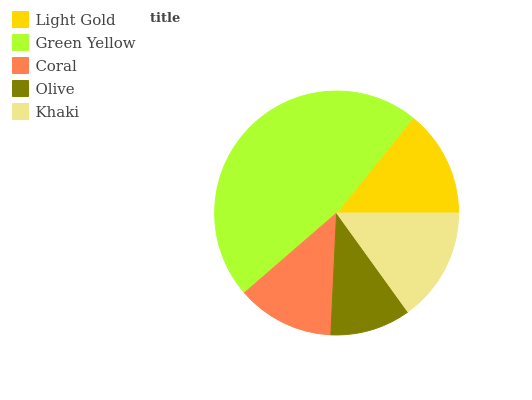Is Olive the minimum?
Answer yes or no. Yes. Is Green Yellow the maximum?
Answer yes or no. Yes. Is Coral the minimum?
Answer yes or no. No. Is Coral the maximum?
Answer yes or no. No. Is Green Yellow greater than Coral?
Answer yes or no. Yes. Is Coral less than Green Yellow?
Answer yes or no. Yes. Is Coral greater than Green Yellow?
Answer yes or no. No. Is Green Yellow less than Coral?
Answer yes or no. No. Is Light Gold the high median?
Answer yes or no. Yes. Is Light Gold the low median?
Answer yes or no. Yes. Is Coral the high median?
Answer yes or no. No. Is Khaki the low median?
Answer yes or no. No. 